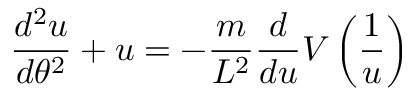<formula> <loc_0><loc_0><loc_500><loc_500>{ \frac { d ^ { 2 } u } { d \theta ^ { 2 } } } + u = - { \frac { m } { L ^ { 2 } } } { \frac { d } { d u } } V \left ( { \frac { 1 } { u } } \right )</formula> 